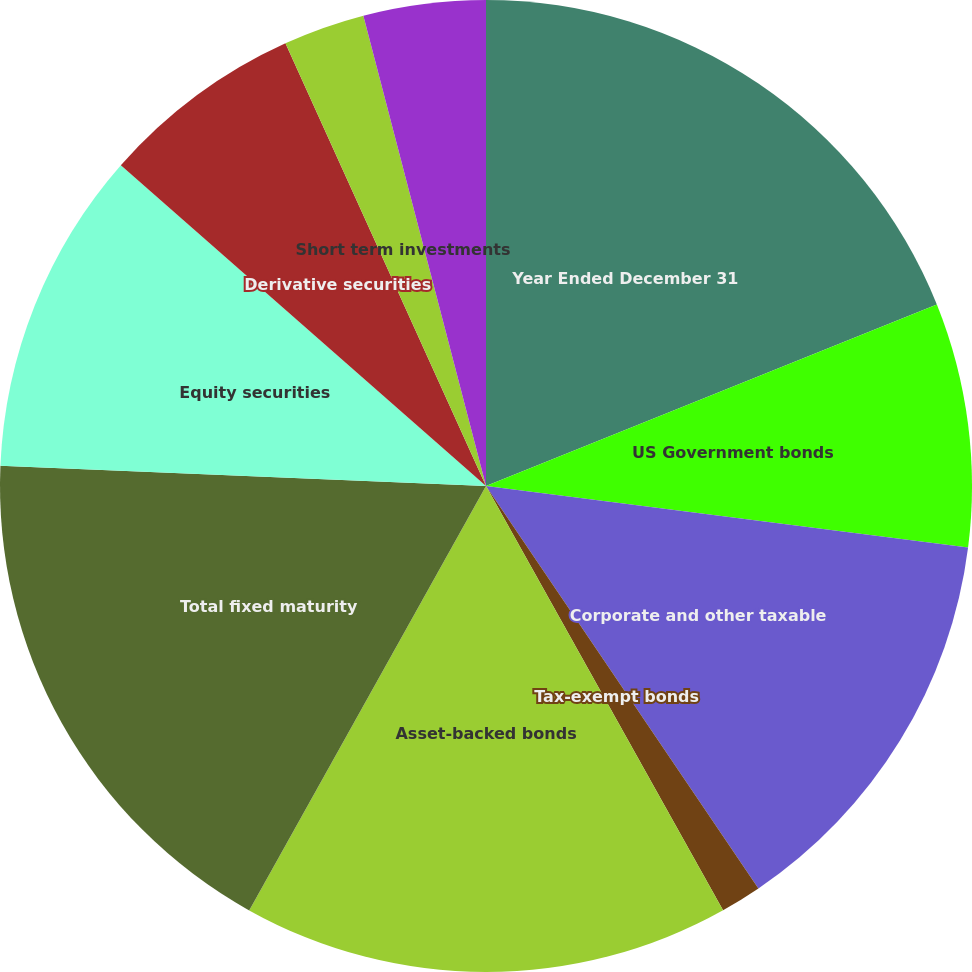Convert chart. <chart><loc_0><loc_0><loc_500><loc_500><pie_chart><fcel>Year Ended December 31<fcel>US Government bonds<fcel>Corporate and other taxable<fcel>Tax-exempt bonds<fcel>Asset-backed bonds<fcel>Total fixed maturity<fcel>Equity securities<fcel>Derivative securities<fcel>Short term investments<fcel>Other invested assets<nl><fcel>18.91%<fcel>8.11%<fcel>13.51%<fcel>1.36%<fcel>16.21%<fcel>17.56%<fcel>10.81%<fcel>6.76%<fcel>2.71%<fcel>4.06%<nl></chart> 